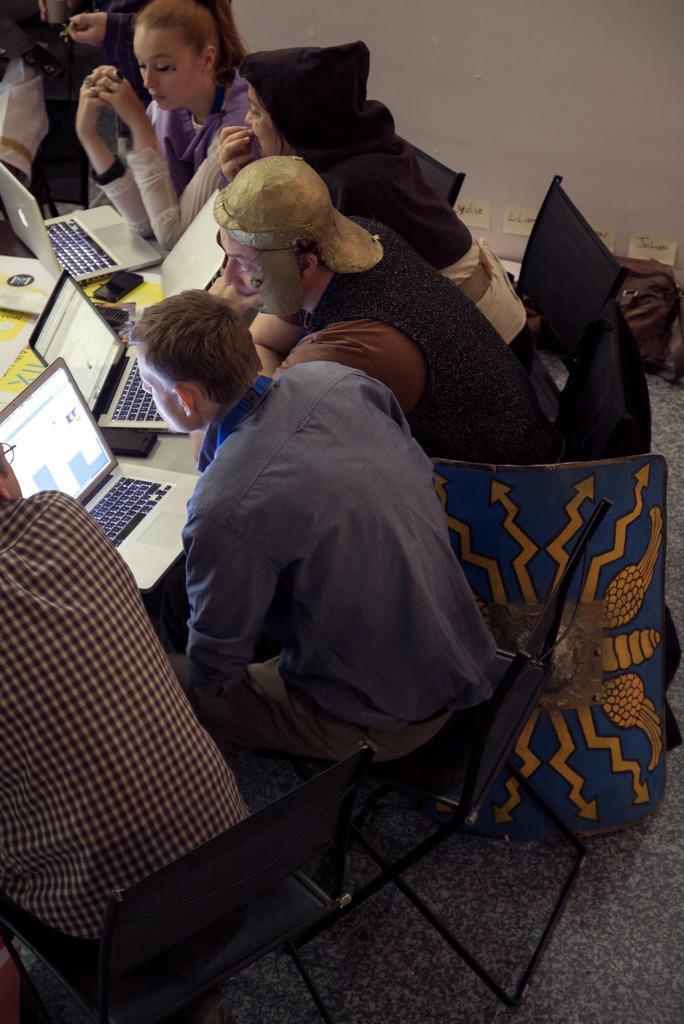Can you describe this image briefly? The image is clicked inside the room. There are many people sitting around the table. To the left, the man is wearing a brown color shirt. In the middle, the man is wearing blue shirt and looking towards the laptop. All are sitting in the chairs. In the background there is a wall. 